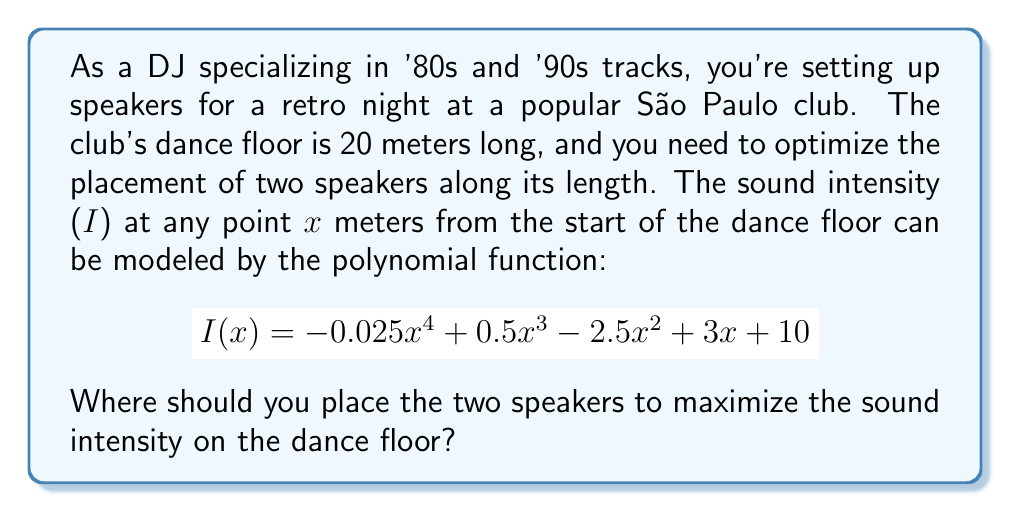Can you solve this math problem? To find the optimal placement for the two speakers, we need to locate the maximum points of the given polynomial function. Here's how we can approach this:

1) First, we need to find the derivative of I(x):
   $$I'(x) = -0.1x^3 + 1.5x^2 - 5x + 3$$

2) To find the critical points, we set I'(x) = 0:
   $$-0.1x^3 + 1.5x^2 - 5x + 3 = 0$$

3) This cubic equation is difficult to solve by factoring. We can use a graphing calculator or computer algebra system to find the roots. The roots are approximately:
   x ≈ 0.6, 5.0, and 9.4

4) We also need to consider the endpoints of our interval [0, 20] as potential maximum points.

5) Now, we evaluate I(x) at these critical points and the endpoints:
   I(0) = 10
   I(0.6) ≈ 11.5
   I(5.0) ≈ 35.4
   I(9.4) ≈ 11.5
   I(20) ≈ -11490

6) The two highest values occur at x ≈ 5.0 and x ≈ 9.4.

Therefore, to maximize the sound intensity, we should place the speakers approximately 5.0 meters and 9.4 meters from the start of the dance floor.
Answer: Place the speakers at approximately 5.0 meters and 9.4 meters from the start of the dance floor. 